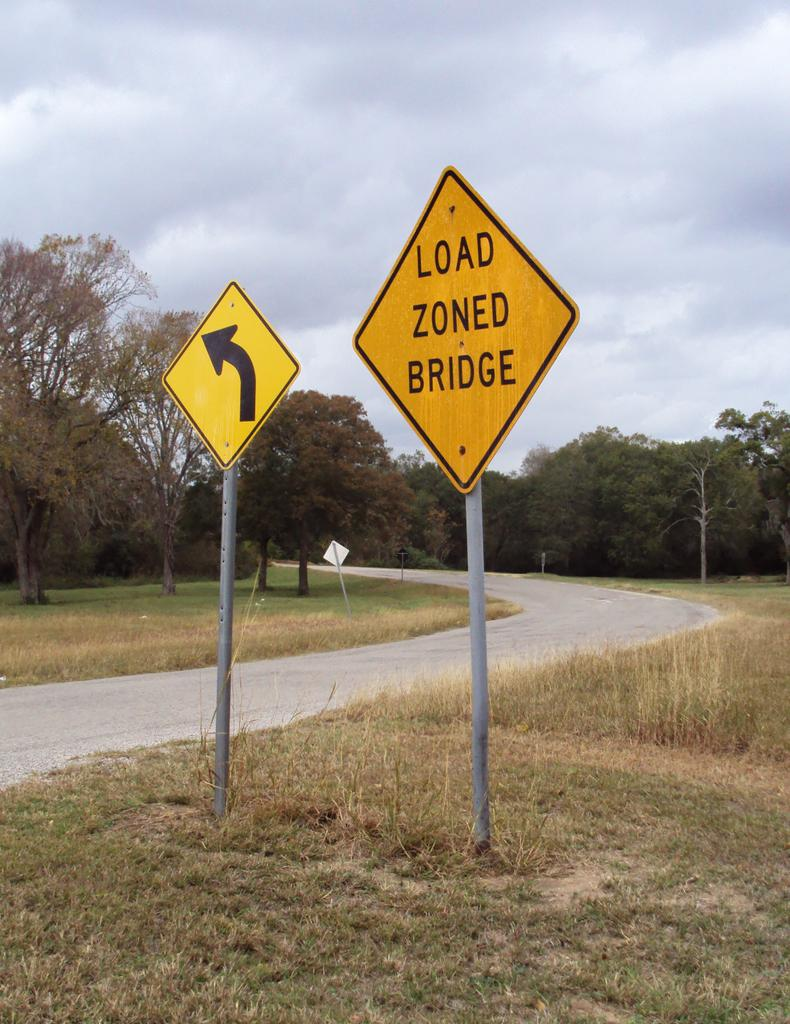<image>
Render a clear and concise summary of the photo. Two street signs for a load zoned bridge and an upcoming curve sign are on the side of a small, service drive. 